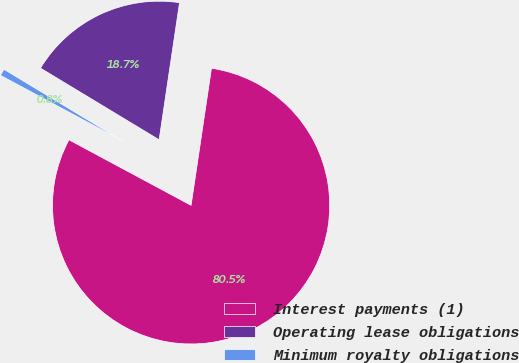Convert chart to OTSL. <chart><loc_0><loc_0><loc_500><loc_500><pie_chart><fcel>Interest payments (1)<fcel>Operating lease obligations<fcel>Minimum royalty obligations<nl><fcel>80.49%<fcel>18.7%<fcel>0.81%<nl></chart> 